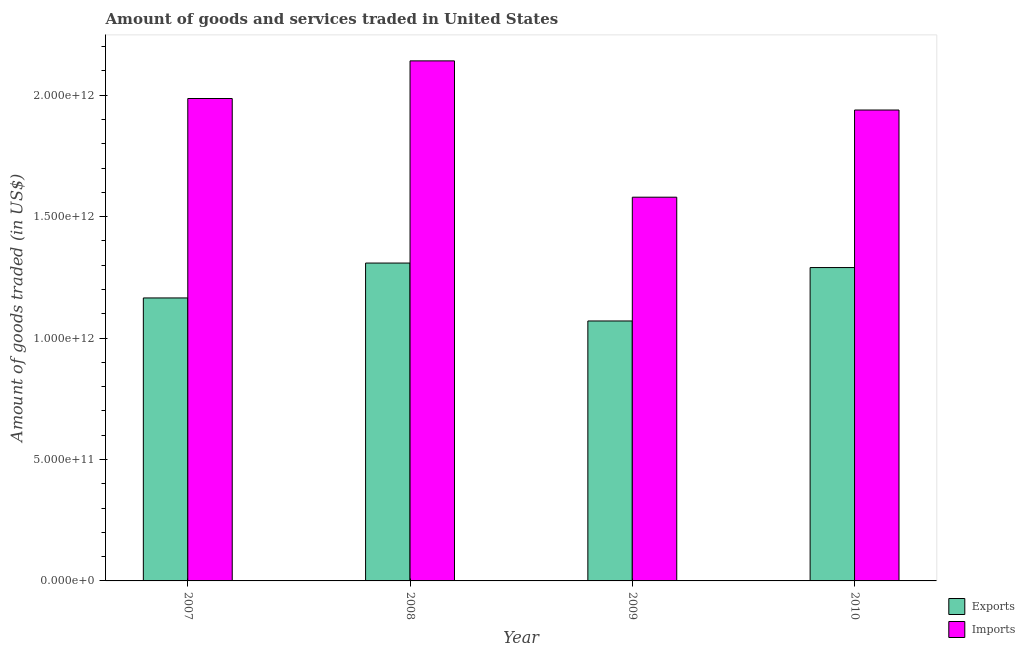How many bars are there on the 1st tick from the left?
Ensure brevity in your answer.  2. How many bars are there on the 1st tick from the right?
Your response must be concise. 2. What is the label of the 4th group of bars from the left?
Keep it short and to the point. 2010. What is the amount of goods imported in 2007?
Provide a short and direct response. 1.99e+12. Across all years, what is the maximum amount of goods imported?
Your response must be concise. 2.14e+12. Across all years, what is the minimum amount of goods exported?
Offer a terse response. 1.07e+12. In which year was the amount of goods imported maximum?
Your response must be concise. 2008. What is the total amount of goods exported in the graph?
Provide a short and direct response. 4.83e+12. What is the difference between the amount of goods exported in 2009 and that in 2010?
Make the answer very short. -2.20e+11. What is the difference between the amount of goods imported in 2008 and the amount of goods exported in 2007?
Your answer should be very brief. 1.55e+11. What is the average amount of goods imported per year?
Make the answer very short. 1.91e+12. In the year 2010, what is the difference between the amount of goods imported and amount of goods exported?
Ensure brevity in your answer.  0. What is the ratio of the amount of goods imported in 2007 to that in 2010?
Your answer should be very brief. 1.02. Is the amount of goods exported in 2007 less than that in 2008?
Provide a short and direct response. Yes. Is the difference between the amount of goods exported in 2008 and 2010 greater than the difference between the amount of goods imported in 2008 and 2010?
Your answer should be very brief. No. What is the difference between the highest and the second highest amount of goods exported?
Provide a succinct answer. 1.85e+1. What is the difference between the highest and the lowest amount of goods imported?
Offer a very short reply. 5.61e+11. In how many years, is the amount of goods exported greater than the average amount of goods exported taken over all years?
Provide a succinct answer. 2. What does the 2nd bar from the left in 2007 represents?
Offer a very short reply. Imports. What does the 1st bar from the right in 2010 represents?
Offer a very short reply. Imports. What is the difference between two consecutive major ticks on the Y-axis?
Ensure brevity in your answer.  5.00e+11. Are the values on the major ticks of Y-axis written in scientific E-notation?
Offer a terse response. Yes. Does the graph contain any zero values?
Your response must be concise. No. How many legend labels are there?
Make the answer very short. 2. What is the title of the graph?
Provide a short and direct response. Amount of goods and services traded in United States. What is the label or title of the Y-axis?
Keep it short and to the point. Amount of goods traded (in US$). What is the Amount of goods traded (in US$) of Exports in 2007?
Your response must be concise. 1.17e+12. What is the Amount of goods traded (in US$) in Imports in 2007?
Provide a succinct answer. 1.99e+12. What is the Amount of goods traded (in US$) in Exports in 2008?
Offer a terse response. 1.31e+12. What is the Amount of goods traded (in US$) of Imports in 2008?
Your response must be concise. 2.14e+12. What is the Amount of goods traded (in US$) in Exports in 2009?
Your answer should be very brief. 1.07e+12. What is the Amount of goods traded (in US$) of Imports in 2009?
Provide a succinct answer. 1.58e+12. What is the Amount of goods traded (in US$) in Exports in 2010?
Provide a short and direct response. 1.29e+12. What is the Amount of goods traded (in US$) in Imports in 2010?
Give a very brief answer. 1.94e+12. Across all years, what is the maximum Amount of goods traded (in US$) in Exports?
Provide a short and direct response. 1.31e+12. Across all years, what is the maximum Amount of goods traded (in US$) of Imports?
Your answer should be compact. 2.14e+12. Across all years, what is the minimum Amount of goods traded (in US$) of Exports?
Offer a terse response. 1.07e+12. Across all years, what is the minimum Amount of goods traded (in US$) of Imports?
Your response must be concise. 1.58e+12. What is the total Amount of goods traded (in US$) in Exports in the graph?
Offer a very short reply. 4.83e+12. What is the total Amount of goods traded (in US$) in Imports in the graph?
Your response must be concise. 7.65e+12. What is the difference between the Amount of goods traded (in US$) in Exports in 2007 and that in 2008?
Offer a very short reply. -1.44e+11. What is the difference between the Amount of goods traded (in US$) of Imports in 2007 and that in 2008?
Make the answer very short. -1.55e+11. What is the difference between the Amount of goods traded (in US$) of Exports in 2007 and that in 2009?
Your response must be concise. 9.48e+1. What is the difference between the Amount of goods traded (in US$) in Imports in 2007 and that in 2009?
Your answer should be compact. 4.06e+11. What is the difference between the Amount of goods traded (in US$) in Exports in 2007 and that in 2010?
Offer a terse response. -1.25e+11. What is the difference between the Amount of goods traded (in US$) in Imports in 2007 and that in 2010?
Offer a very short reply. 4.74e+1. What is the difference between the Amount of goods traded (in US$) of Exports in 2008 and that in 2009?
Your response must be concise. 2.38e+11. What is the difference between the Amount of goods traded (in US$) in Imports in 2008 and that in 2009?
Offer a terse response. 5.61e+11. What is the difference between the Amount of goods traded (in US$) in Exports in 2008 and that in 2010?
Make the answer very short. 1.85e+1. What is the difference between the Amount of goods traded (in US$) of Imports in 2008 and that in 2010?
Your answer should be compact. 2.02e+11. What is the difference between the Amount of goods traded (in US$) in Exports in 2009 and that in 2010?
Your answer should be compact. -2.20e+11. What is the difference between the Amount of goods traded (in US$) in Imports in 2009 and that in 2010?
Ensure brevity in your answer.  -3.59e+11. What is the difference between the Amount of goods traded (in US$) in Exports in 2007 and the Amount of goods traded (in US$) in Imports in 2008?
Your answer should be very brief. -9.76e+11. What is the difference between the Amount of goods traded (in US$) in Exports in 2007 and the Amount of goods traded (in US$) in Imports in 2009?
Keep it short and to the point. -4.15e+11. What is the difference between the Amount of goods traded (in US$) of Exports in 2007 and the Amount of goods traded (in US$) of Imports in 2010?
Your response must be concise. -7.74e+11. What is the difference between the Amount of goods traded (in US$) of Exports in 2008 and the Amount of goods traded (in US$) of Imports in 2009?
Give a very brief answer. -2.71e+11. What is the difference between the Amount of goods traded (in US$) of Exports in 2008 and the Amount of goods traded (in US$) of Imports in 2010?
Provide a short and direct response. -6.30e+11. What is the difference between the Amount of goods traded (in US$) in Exports in 2009 and the Amount of goods traded (in US$) in Imports in 2010?
Your response must be concise. -8.69e+11. What is the average Amount of goods traded (in US$) of Exports per year?
Your answer should be very brief. 1.21e+12. What is the average Amount of goods traded (in US$) of Imports per year?
Offer a terse response. 1.91e+12. In the year 2007, what is the difference between the Amount of goods traded (in US$) of Exports and Amount of goods traded (in US$) of Imports?
Offer a very short reply. -8.21e+11. In the year 2008, what is the difference between the Amount of goods traded (in US$) in Exports and Amount of goods traded (in US$) in Imports?
Offer a terse response. -8.32e+11. In the year 2009, what is the difference between the Amount of goods traded (in US$) of Exports and Amount of goods traded (in US$) of Imports?
Your answer should be compact. -5.10e+11. In the year 2010, what is the difference between the Amount of goods traded (in US$) of Exports and Amount of goods traded (in US$) of Imports?
Provide a succinct answer. -6.49e+11. What is the ratio of the Amount of goods traded (in US$) in Exports in 2007 to that in 2008?
Give a very brief answer. 0.89. What is the ratio of the Amount of goods traded (in US$) in Imports in 2007 to that in 2008?
Offer a terse response. 0.93. What is the ratio of the Amount of goods traded (in US$) in Exports in 2007 to that in 2009?
Offer a terse response. 1.09. What is the ratio of the Amount of goods traded (in US$) in Imports in 2007 to that in 2009?
Keep it short and to the point. 1.26. What is the ratio of the Amount of goods traded (in US$) in Exports in 2007 to that in 2010?
Your response must be concise. 0.9. What is the ratio of the Amount of goods traded (in US$) of Imports in 2007 to that in 2010?
Provide a succinct answer. 1.02. What is the ratio of the Amount of goods traded (in US$) in Exports in 2008 to that in 2009?
Keep it short and to the point. 1.22. What is the ratio of the Amount of goods traded (in US$) of Imports in 2008 to that in 2009?
Your response must be concise. 1.36. What is the ratio of the Amount of goods traded (in US$) in Exports in 2008 to that in 2010?
Make the answer very short. 1.01. What is the ratio of the Amount of goods traded (in US$) in Imports in 2008 to that in 2010?
Ensure brevity in your answer.  1.1. What is the ratio of the Amount of goods traded (in US$) in Exports in 2009 to that in 2010?
Give a very brief answer. 0.83. What is the ratio of the Amount of goods traded (in US$) of Imports in 2009 to that in 2010?
Offer a very short reply. 0.81. What is the difference between the highest and the second highest Amount of goods traded (in US$) of Exports?
Make the answer very short. 1.85e+1. What is the difference between the highest and the second highest Amount of goods traded (in US$) in Imports?
Keep it short and to the point. 1.55e+11. What is the difference between the highest and the lowest Amount of goods traded (in US$) in Exports?
Provide a succinct answer. 2.38e+11. What is the difference between the highest and the lowest Amount of goods traded (in US$) of Imports?
Ensure brevity in your answer.  5.61e+11. 